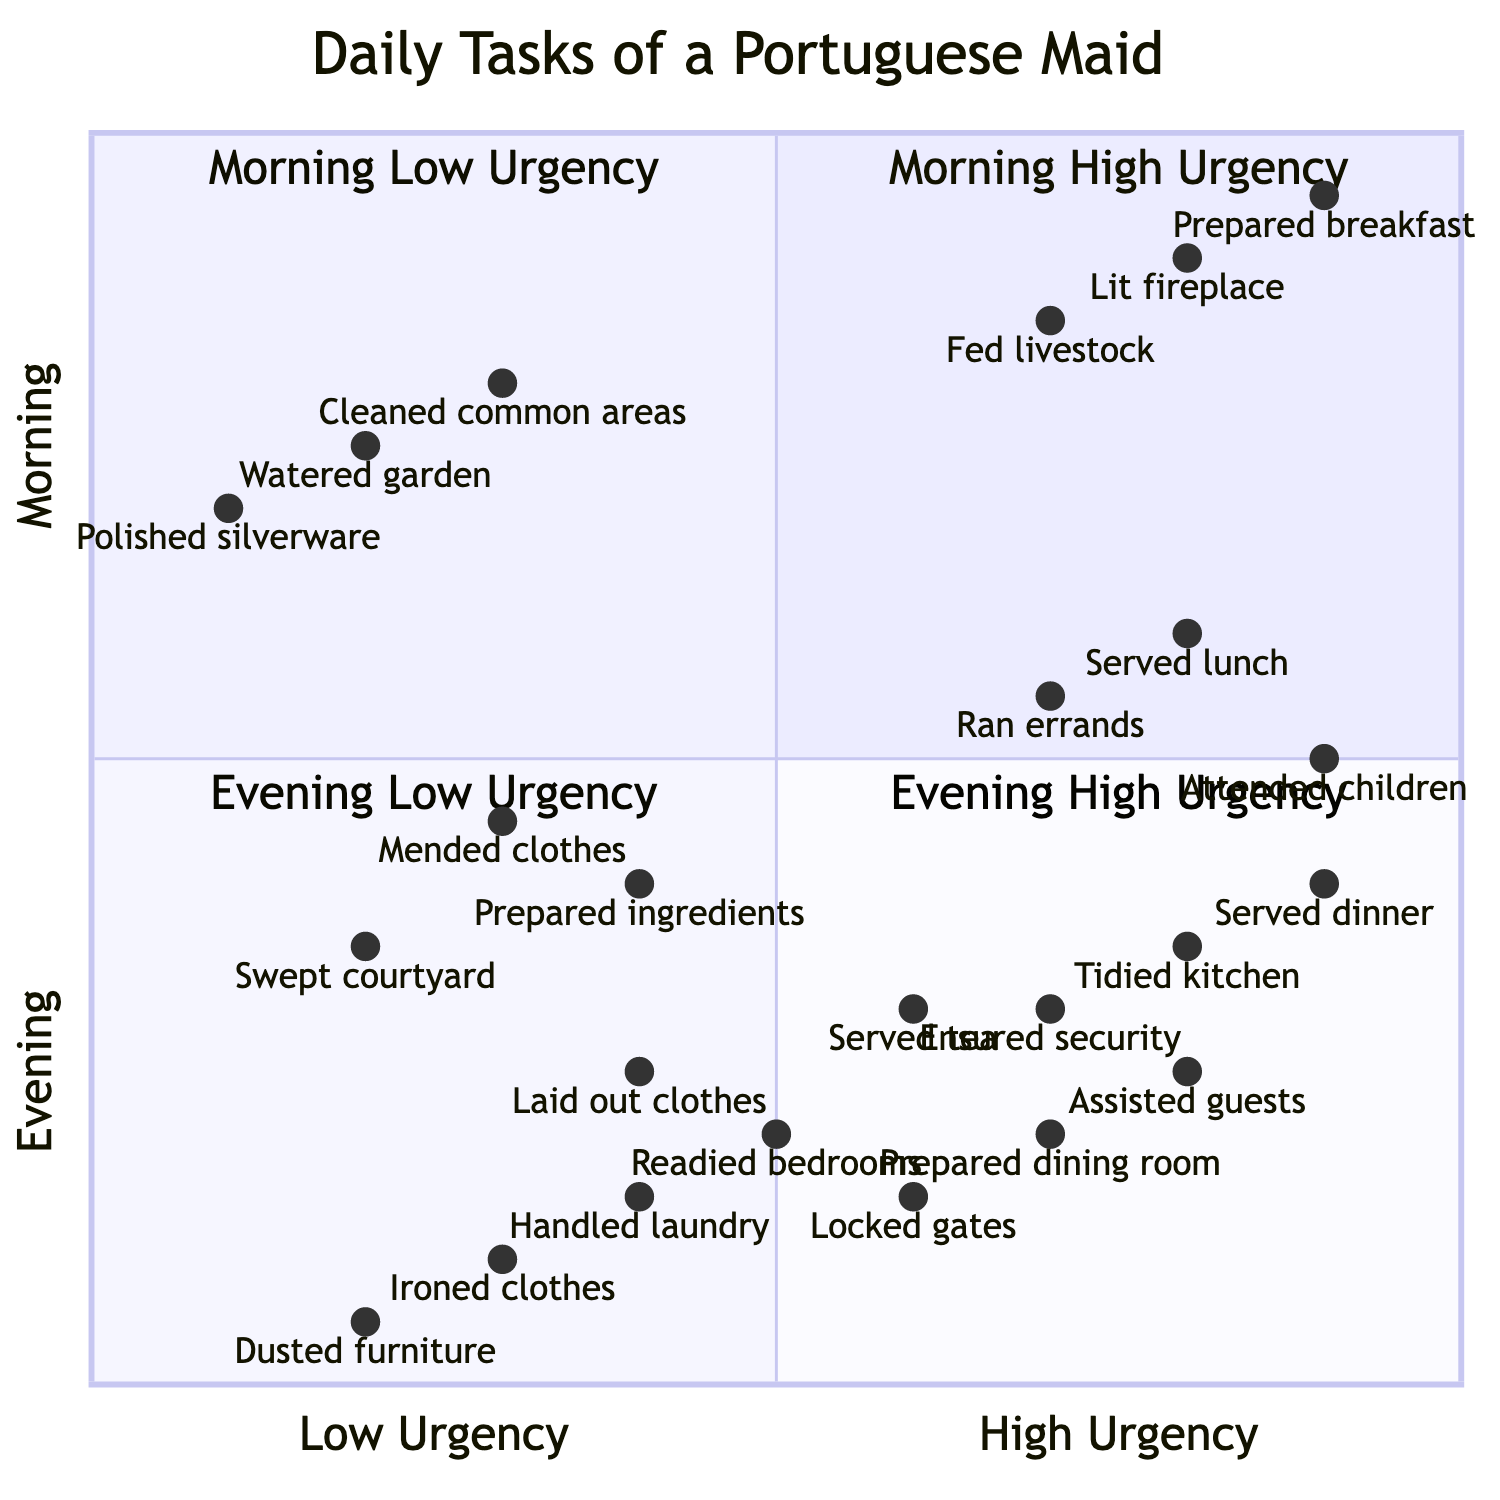What high urgency task is in the morning? In the diagram, under the quadrant for Morning High Urgency, we can see the tasks listed. The three tasks listed are "Lit the fireplace," "Prepared breakfast for the family," and "Fed the livestock."
Answer: Lit the fireplace How many low urgency tasks are there in the afternoon? Checking the quadrant for Afternoon Low Urgency, the tasks listed include "Handled laundry," "Ironed clothes," and "Dusted the furniture." There are a total of three tasks in this quadrant.
Answer: 3 What is the lowest urgency task in the evening? In the quadrant for Evening Low Urgency, the tasks are "Laid out clothes for the next day," "Readied the bedrooms," and "Locked up the outer gates." Among these, "Dusted the furniture" is the least urgent, but looking specifically at the evening quadrant, "Locked up the outer gates" has the lowest urgency contextually.
Answer: Locked up the outer gates Which midday high urgency task is focused on children's needs? Under the Midday High Urgency quadrant, we see the task "Attended to children's needs." This task directly relates to the care and needs of the children in the household.
Answer: Attended to children's needs How does the importance of "Served dinner" compare to "Served lunch"? "Served dinner" is listed in the Evening High Urgency quadrant, while "Served lunch" is in the Midday High Urgency quadrant. The placement indicates both are high urgency tasks but occur at different times of the day, highlighting the importance of scheduling. Therefore, they have similar urgency but are contextually different.
Answer: Both are high urgency tasks 